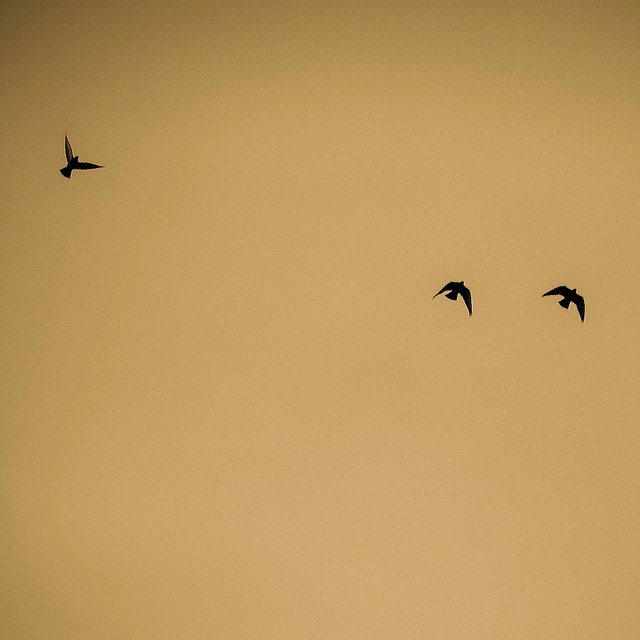<image>How does this bird's wingspan compare to that of a typical adult bald eagle? It is unknown how this bird's wingspan compares to that of a typical adult bald eagle. How does this bird's wingspan compare to that of a typical adult bald eagle? I don't know how this bird's wingspan compares to that of a typical adult bald eagle. It can be smaller, much smaller or average. 